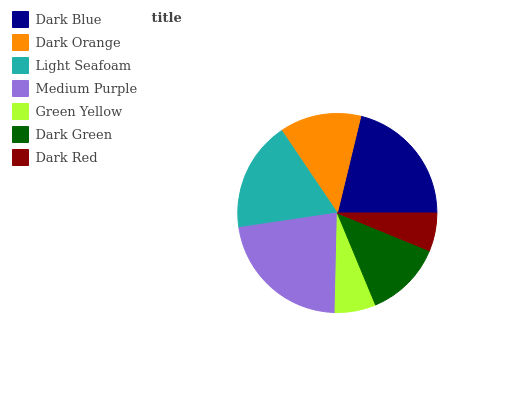Is Dark Red the minimum?
Answer yes or no. Yes. Is Medium Purple the maximum?
Answer yes or no. Yes. Is Dark Orange the minimum?
Answer yes or no. No. Is Dark Orange the maximum?
Answer yes or no. No. Is Dark Blue greater than Dark Orange?
Answer yes or no. Yes. Is Dark Orange less than Dark Blue?
Answer yes or no. Yes. Is Dark Orange greater than Dark Blue?
Answer yes or no. No. Is Dark Blue less than Dark Orange?
Answer yes or no. No. Is Dark Orange the high median?
Answer yes or no. Yes. Is Dark Orange the low median?
Answer yes or no. Yes. Is Green Yellow the high median?
Answer yes or no. No. Is Green Yellow the low median?
Answer yes or no. No. 